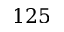<formula> <loc_0><loc_0><loc_500><loc_500>1 2 5</formula> 